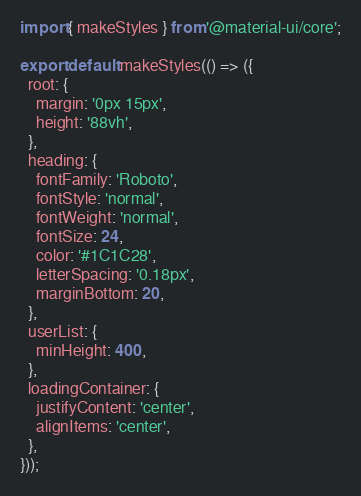Convert code to text. <code><loc_0><loc_0><loc_500><loc_500><_TypeScript_>import { makeStyles } from '@material-ui/core';

export default makeStyles(() => ({
  root: {
    margin: '0px 15px',
    height: '88vh',
  },
  heading: {
    fontFamily: 'Roboto',
    fontStyle: 'normal',
    fontWeight: 'normal',
    fontSize: 24,
    color: '#1C1C28',
    letterSpacing: '0.18px',
    marginBottom: 20,
  },
  userList: {
    minHeight: 400,
  },
  loadingContainer: {
    justifyContent: 'center',
    alignItems: 'center',
  },
}));
</code> 